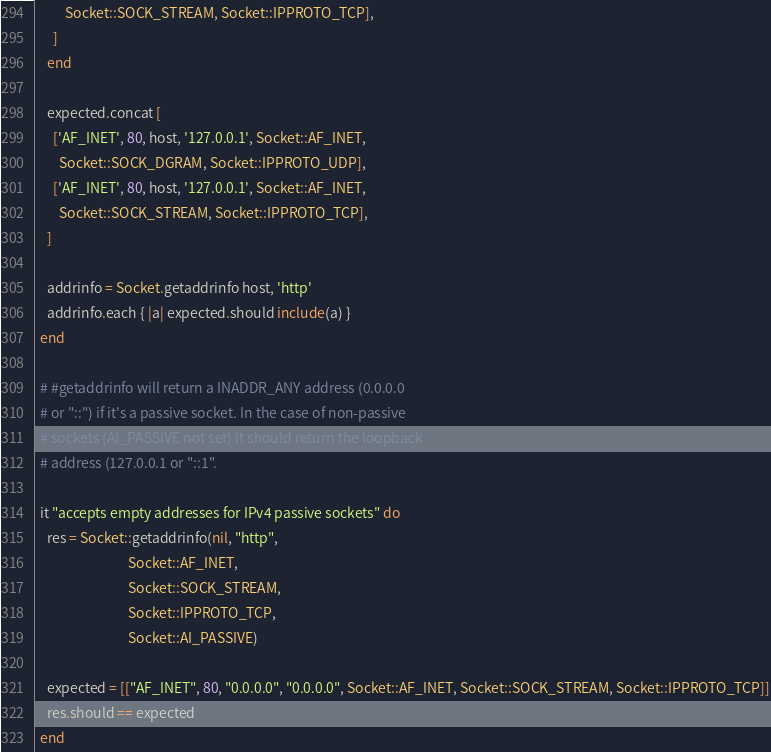Convert code to text. <code><loc_0><loc_0><loc_500><loc_500><_Ruby_>          Socket::SOCK_STREAM, Socket::IPPROTO_TCP],
      ]
    end

    expected.concat [
      ['AF_INET', 80, host, '127.0.0.1', Socket::AF_INET,
        Socket::SOCK_DGRAM, Socket::IPPROTO_UDP],
      ['AF_INET', 80, host, '127.0.0.1', Socket::AF_INET,
        Socket::SOCK_STREAM, Socket::IPPROTO_TCP],
    ]

    addrinfo = Socket.getaddrinfo host, 'http'
    addrinfo.each { |a| expected.should include(a) }
  end

  # #getaddrinfo will return a INADDR_ANY address (0.0.0.0
  # or "::") if it's a passive socket. In the case of non-passive 
  # sockets (AI_PASSIVE not set) it should return the loopback 
  # address (127.0.0.1 or "::1".

  it "accepts empty addresses for IPv4 passive sockets" do
    res = Socket::getaddrinfo(nil, "http", 
                              Socket::AF_INET, 
                              Socket::SOCK_STREAM, 
                              Socket::IPPROTO_TCP,
                              Socket::AI_PASSIVE)  

    expected = [["AF_INET", 80, "0.0.0.0", "0.0.0.0", Socket::AF_INET, Socket::SOCK_STREAM, Socket::IPPROTO_TCP]]
    res.should == expected
  end
</code> 